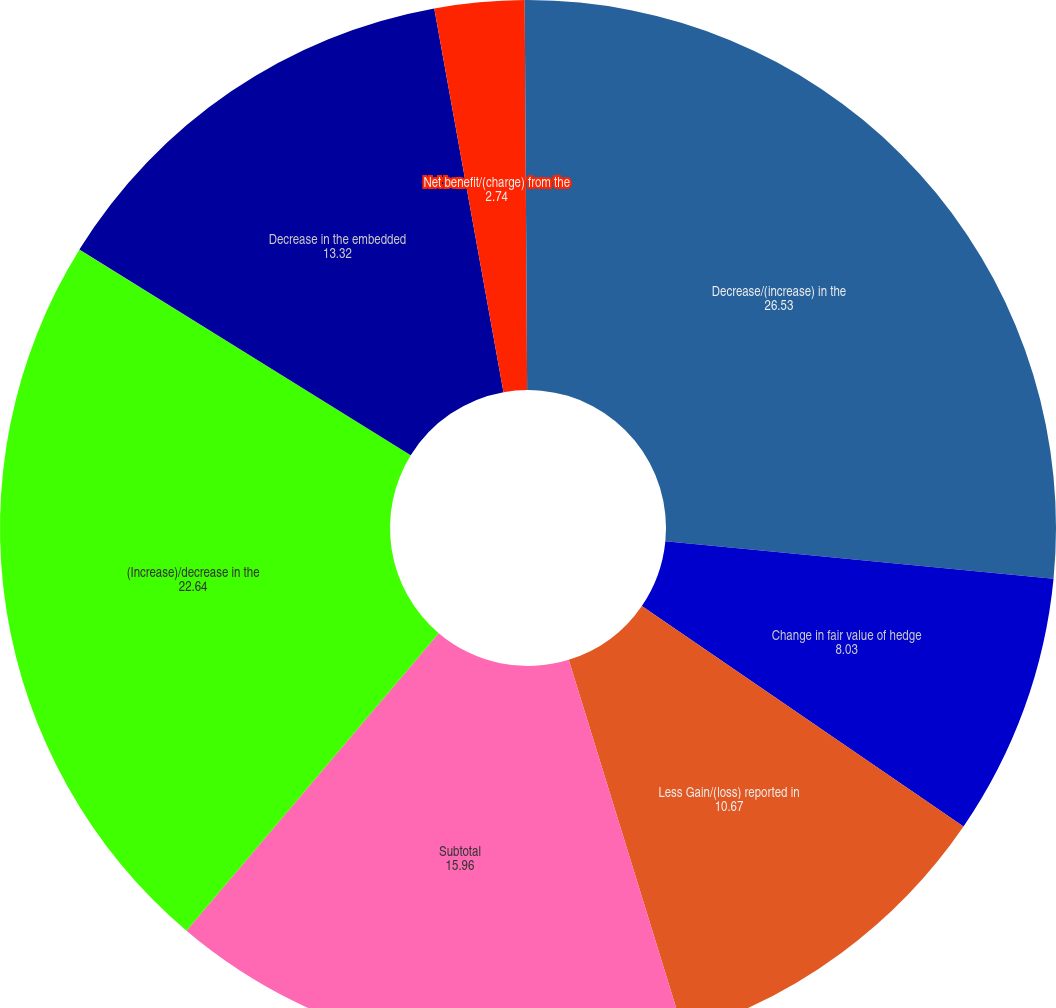Convert chart. <chart><loc_0><loc_0><loc_500><loc_500><pie_chart><fcel>Decrease/(increase) in the<fcel>Change in fair value of hedge<fcel>Less Gain/(loss) reported in<fcel>Subtotal<fcel>(Increase)/decrease in the<fcel>Decrease in the embedded<fcel>Net benefit/(charge) from the<fcel>Related benefit/(charge) to<nl><fcel>26.53%<fcel>8.03%<fcel>10.67%<fcel>15.96%<fcel>22.64%<fcel>13.32%<fcel>2.74%<fcel>0.1%<nl></chart> 